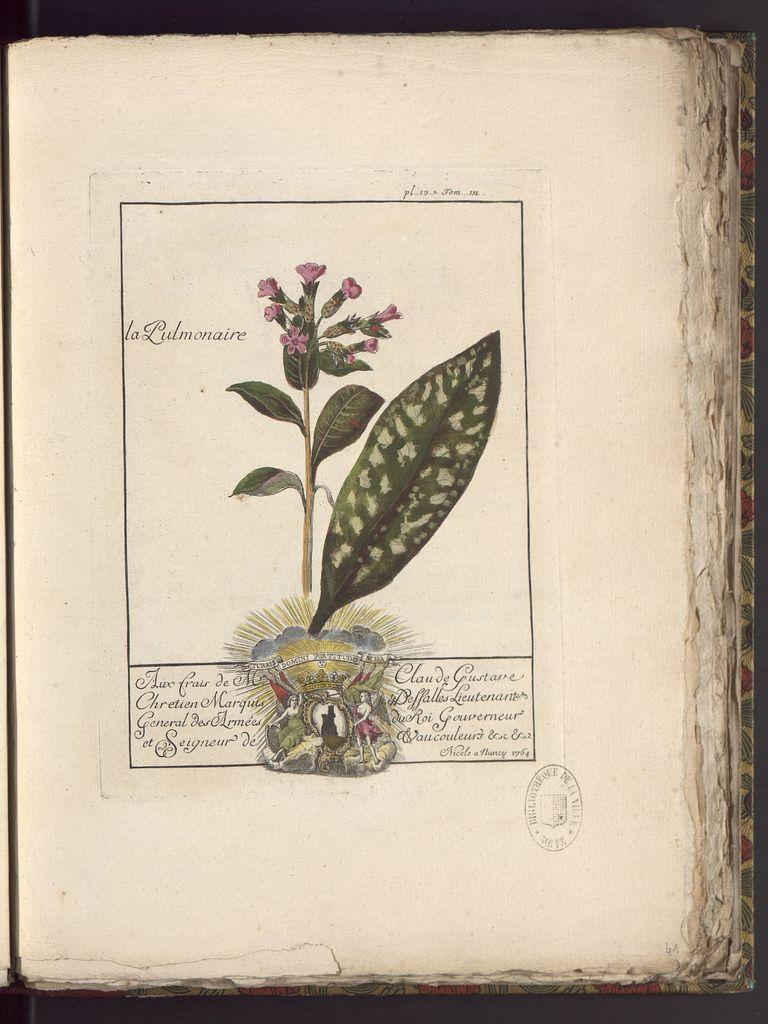What is the main object in the middle of the image? There is a book in the middle of the image. What is placed on top of the book? There is paper on the book. What is on the paper? There is a plant on the paper. What can be observed on the plant? Leaves and flowers are visible on the plant. Are there any additional features on the plant? Yes, there is a logo and text on the plant. What type of humor can be seen in the image? There is no humor present in the image; it features a book, paper, and a plant with leaves, flowers, a logo, and text. 